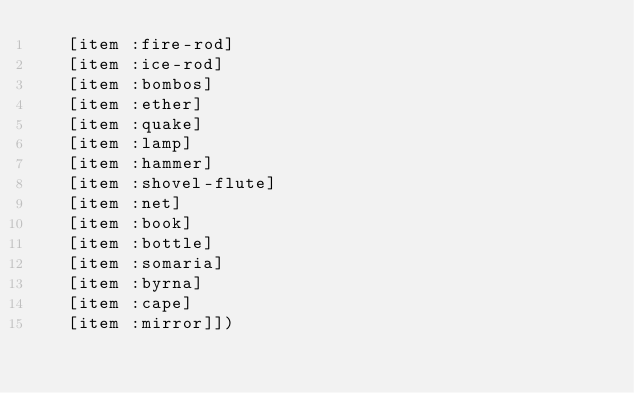Convert code to text. <code><loc_0><loc_0><loc_500><loc_500><_Clojure_>   [item :fire-rod]
   [item :ice-rod]
   [item :bombos]
   [item :ether]
   [item :quake]
   [item :lamp]
   [item :hammer]
   [item :shovel-flute]
   [item :net]
   [item :book]
   [item :bottle]
   [item :somaria]
   [item :byrna]
   [item :cape]
   [item :mirror]])</code> 